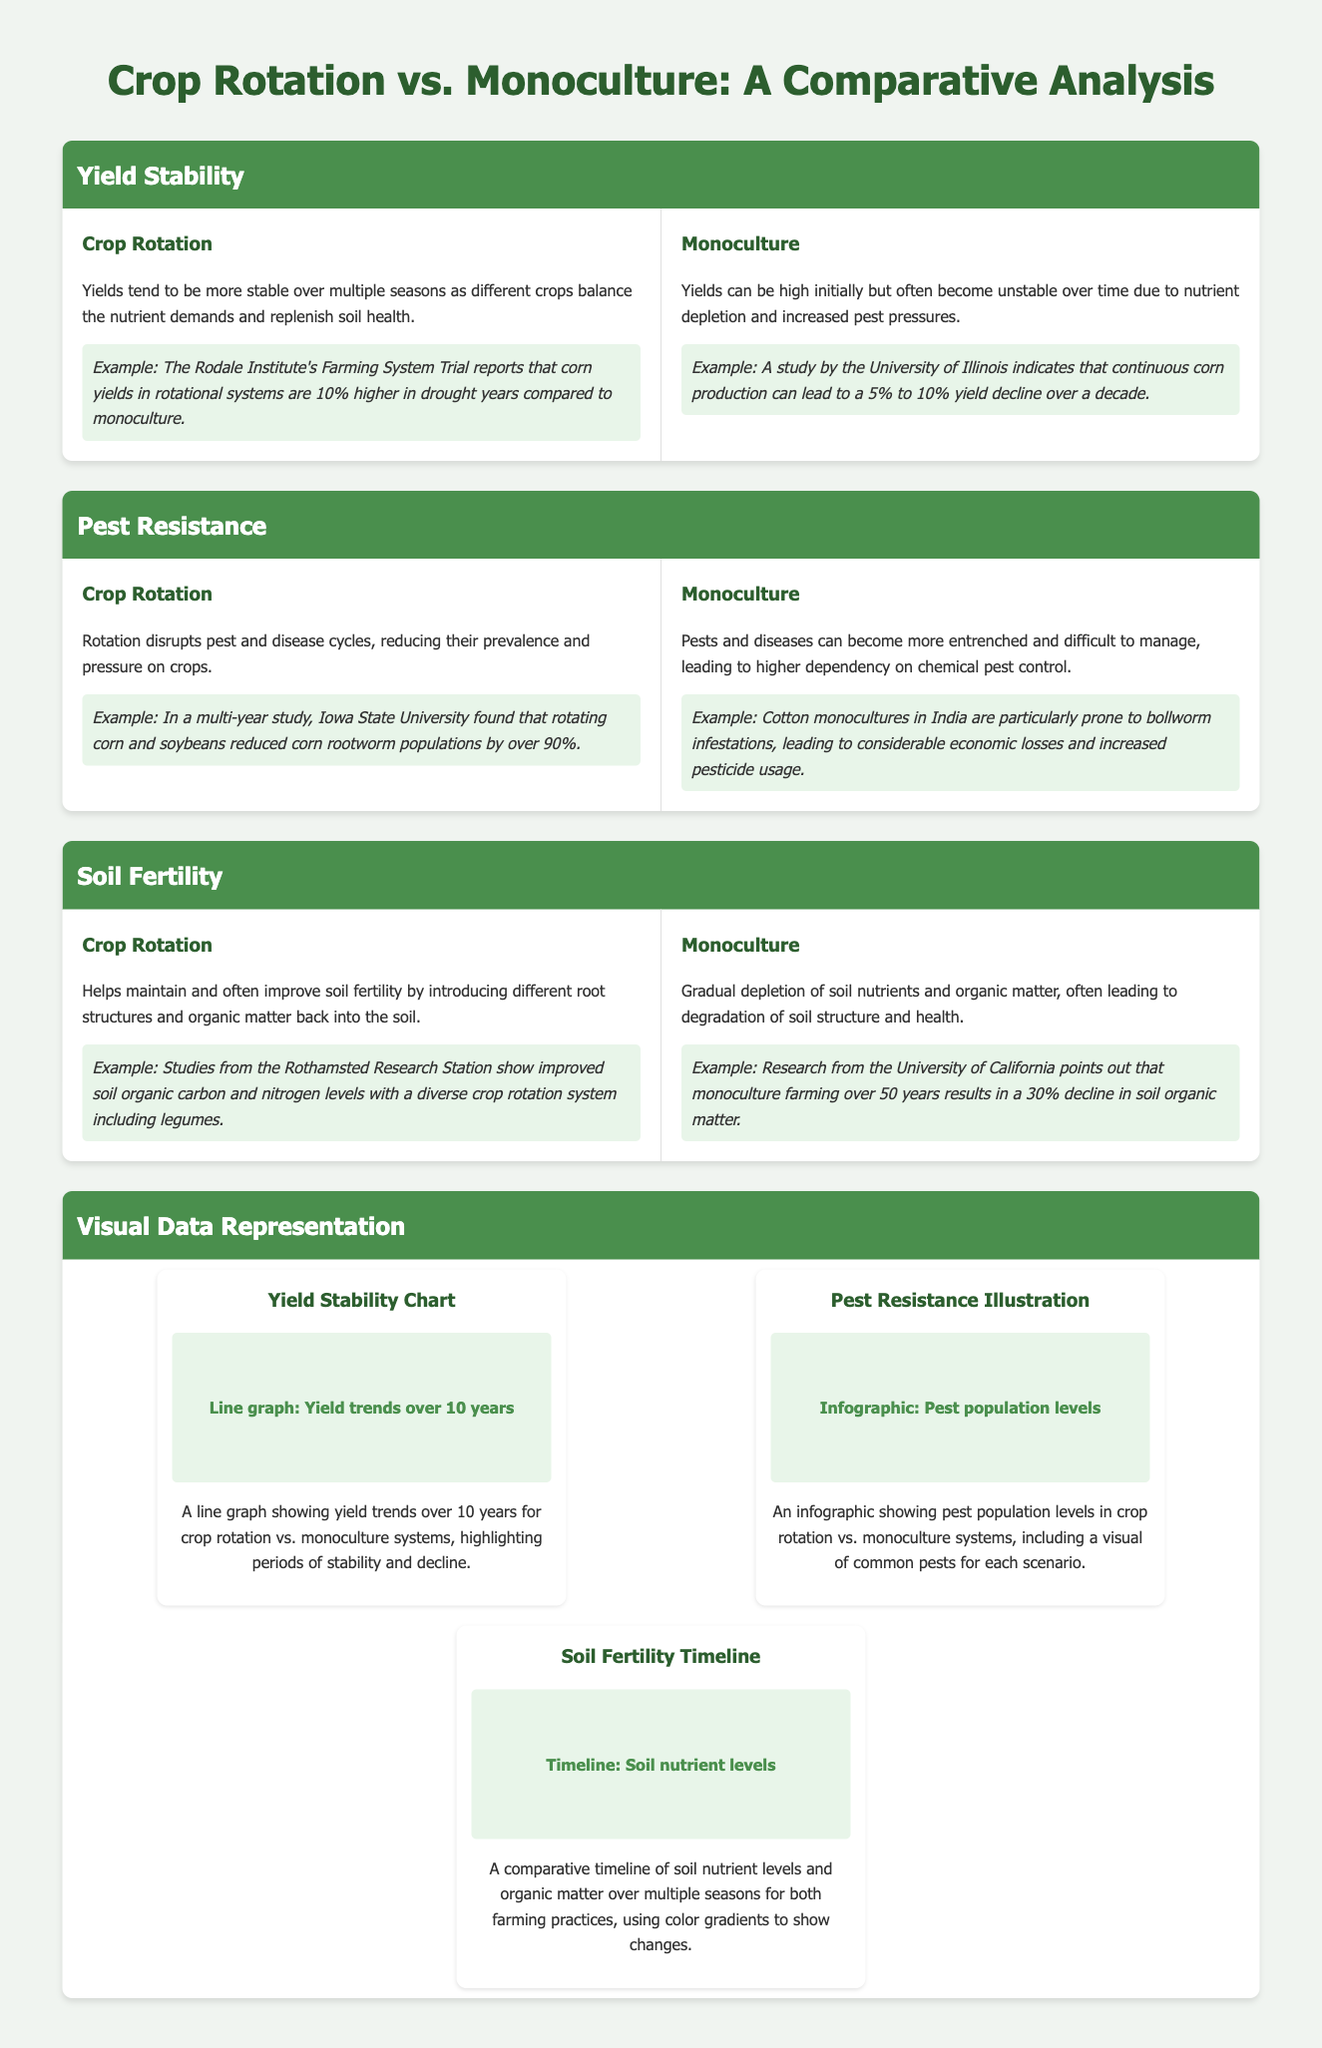What is the yield difference during drought years between crop rotation and monoculture? The document states that corn yields in rotational systems are 10% higher in drought years compared to monoculture.
Answer: 10% Which crop pairing was studied by Iowa State University for pest resistance? The document mentions that rotating corn and soybeans reduced corn rootworm populations by over 90%.
Answer: Corn and soybeans What percentage of yield decline is observed in continuous corn production over a decade? A study by the University of Illinois indicates that continuous corn production can lead to a 5% to 10% yield decline over a decade.
Answer: 5% to 10% What happens to soil fertility in crop rotation according to studies from Rothamsted Research Station? The studies indicate improved soil organic carbon and nitrogen levels with a diverse crop rotation system including legumes.
Answer: Improved What is the visual data representation format for yield stability? The document describes a line graph showing yield trends over 10 years for crop rotation vs. monoculture systems.
Answer: Line graph How much decline in soil organic matter is noted after 50 years of monoculture farming? Research from the University of California points out that monoculture farming over 50 years results in a 30% decline in soil organic matter.
Answer: 30% Which farming practice tends to disrupt pest and disease cycles? The document states that crop rotation disrupts pest and disease cycles, reducing their prevalence and pressure on crops.
Answer: Crop rotation What type of chart illustrates pest population levels in the document? The document describes an infographic showing pest population levels in crop rotation vs. monoculture systems.
Answer: Infographic 